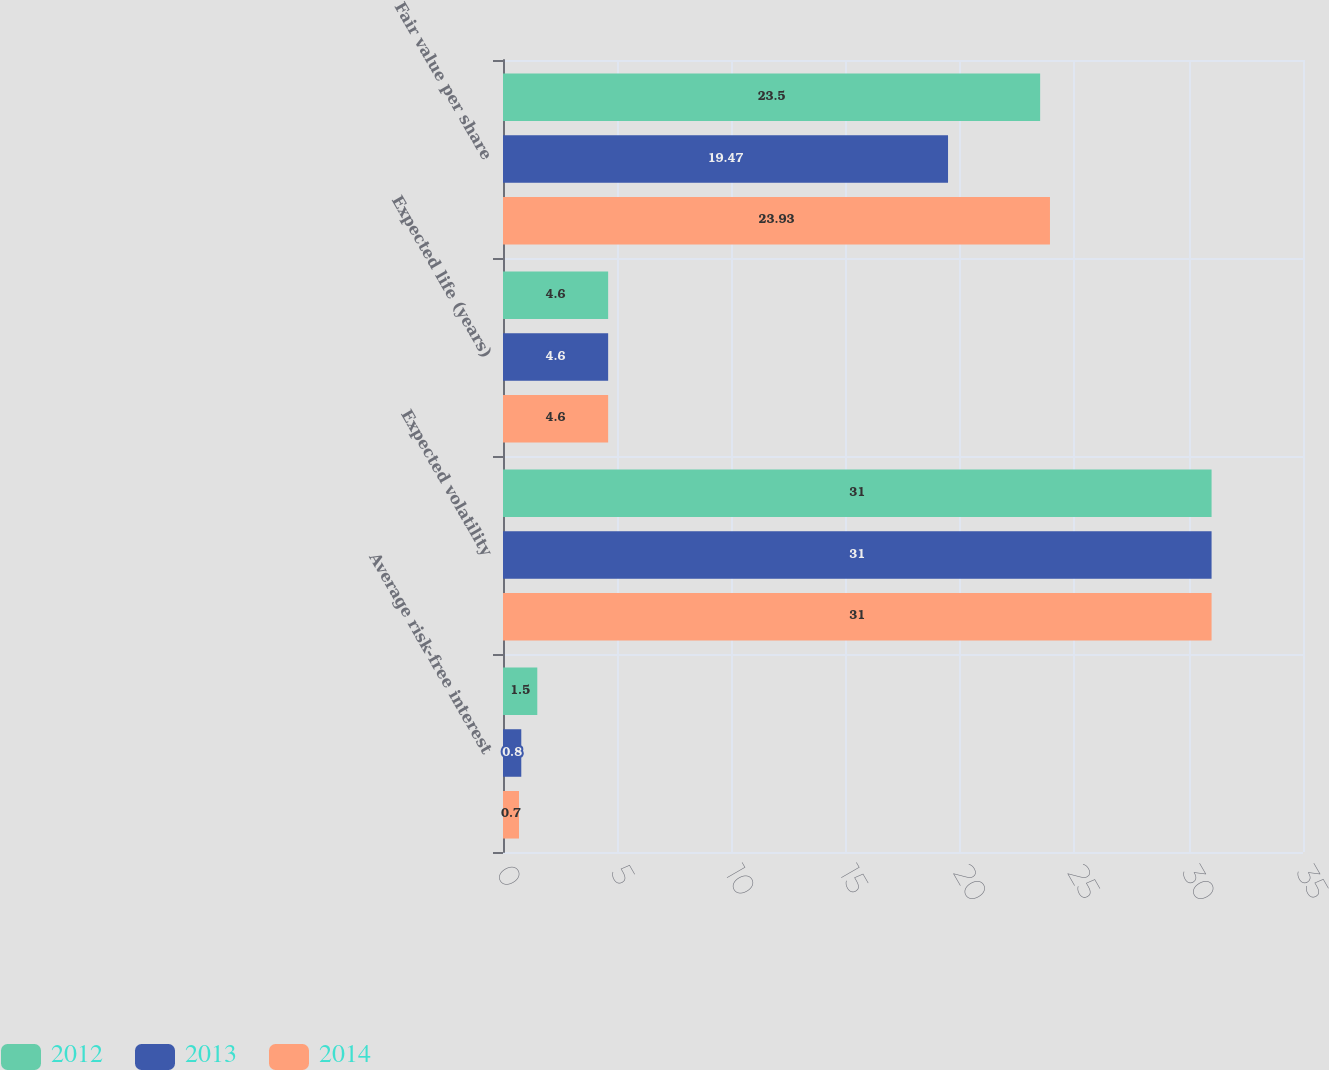Convert chart. <chart><loc_0><loc_0><loc_500><loc_500><stacked_bar_chart><ecel><fcel>Average risk-free interest<fcel>Expected volatility<fcel>Expected life (years)<fcel>Fair value per share<nl><fcel>2012<fcel>1.5<fcel>31<fcel>4.6<fcel>23.5<nl><fcel>2013<fcel>0.8<fcel>31<fcel>4.6<fcel>19.47<nl><fcel>2014<fcel>0.7<fcel>31<fcel>4.6<fcel>23.93<nl></chart> 